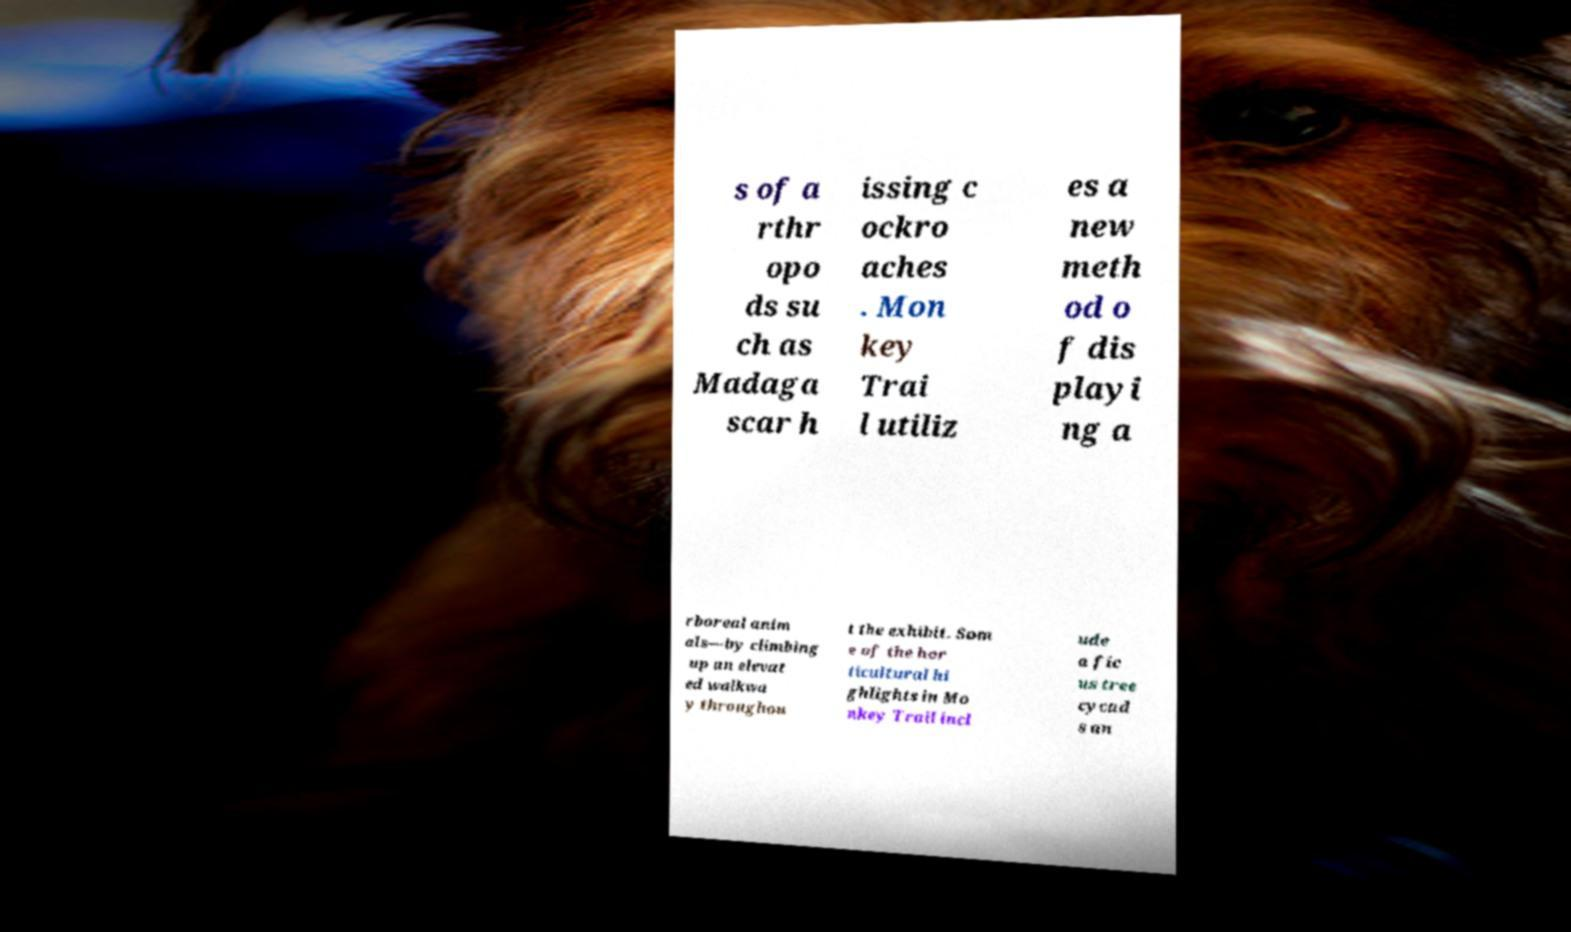Please identify and transcribe the text found in this image. s of a rthr opo ds su ch as Madaga scar h issing c ockro aches . Mon key Trai l utiliz es a new meth od o f dis playi ng a rboreal anim als—by climbing up an elevat ed walkwa y throughou t the exhibit. Som e of the hor ticultural hi ghlights in Mo nkey Trail incl ude a fic us tree cycad s an 